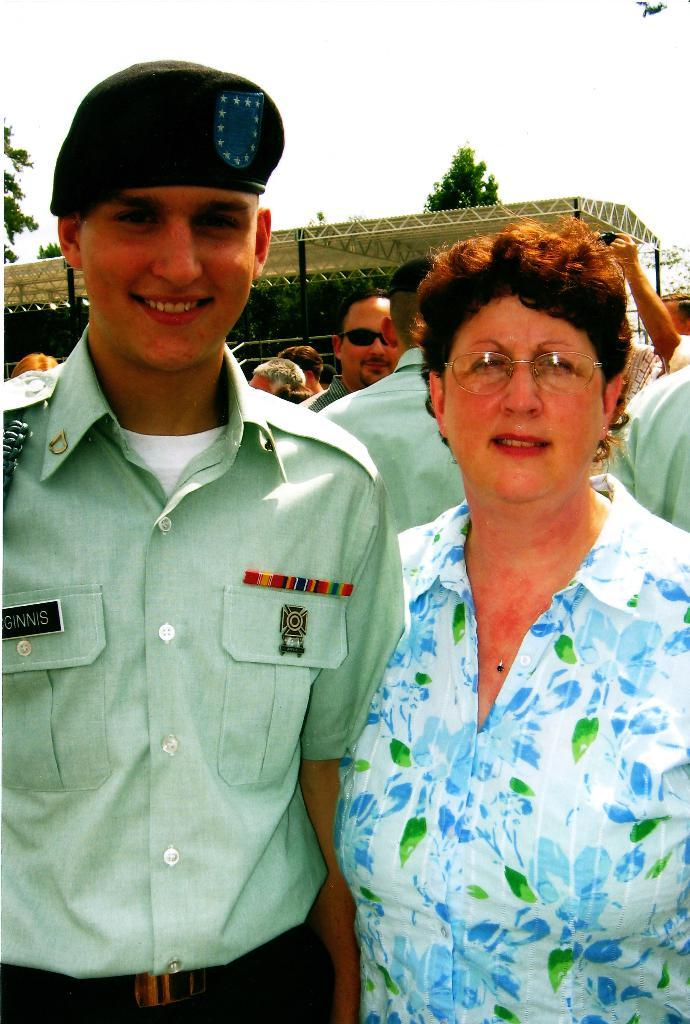How many people are in the foreground of the image? There are two persons standing in the foreground of the image. What can be seen in the background of the image? There is a group of people and poles visible in the background of the image. What type of vegetation is present in the background of the image? There are trees in the background of the image. What type of weather can be seen in the image, with rain and thunder? There is no mention of rain or thunder in the image. The image only shows two persons in the foreground and a group of people and poles in the background, along with trees. 